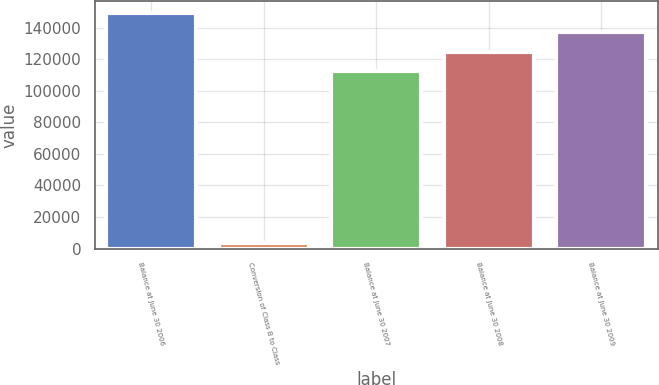Convert chart to OTSL. <chart><loc_0><loc_0><loc_500><loc_500><bar_chart><fcel>Balance at June 30 2006<fcel>Conversion of Class B to Class<fcel>Balance at June 30 2007<fcel>Balance at June 30 2008<fcel>Balance at June 30 2009<nl><fcel>149410<fcel>3501.1<fcel>112523<fcel>124819<fcel>137114<nl></chart> 